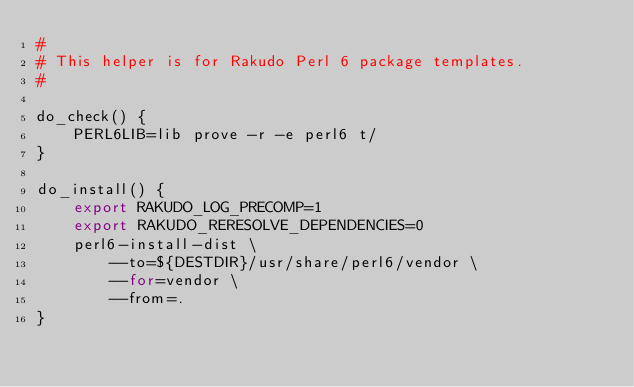Convert code to text. <code><loc_0><loc_0><loc_500><loc_500><_Bash_>#
# This helper is for Rakudo Perl 6 package templates.
#

do_check() {
	PERL6LIB=lib prove -r -e perl6 t/
}

do_install() {
	export RAKUDO_LOG_PRECOMP=1
	export RAKUDO_RERESOLVE_DEPENDENCIES=0
	perl6-install-dist \
		--to=${DESTDIR}/usr/share/perl6/vendor \
		--for=vendor \
		--from=.
}
</code> 